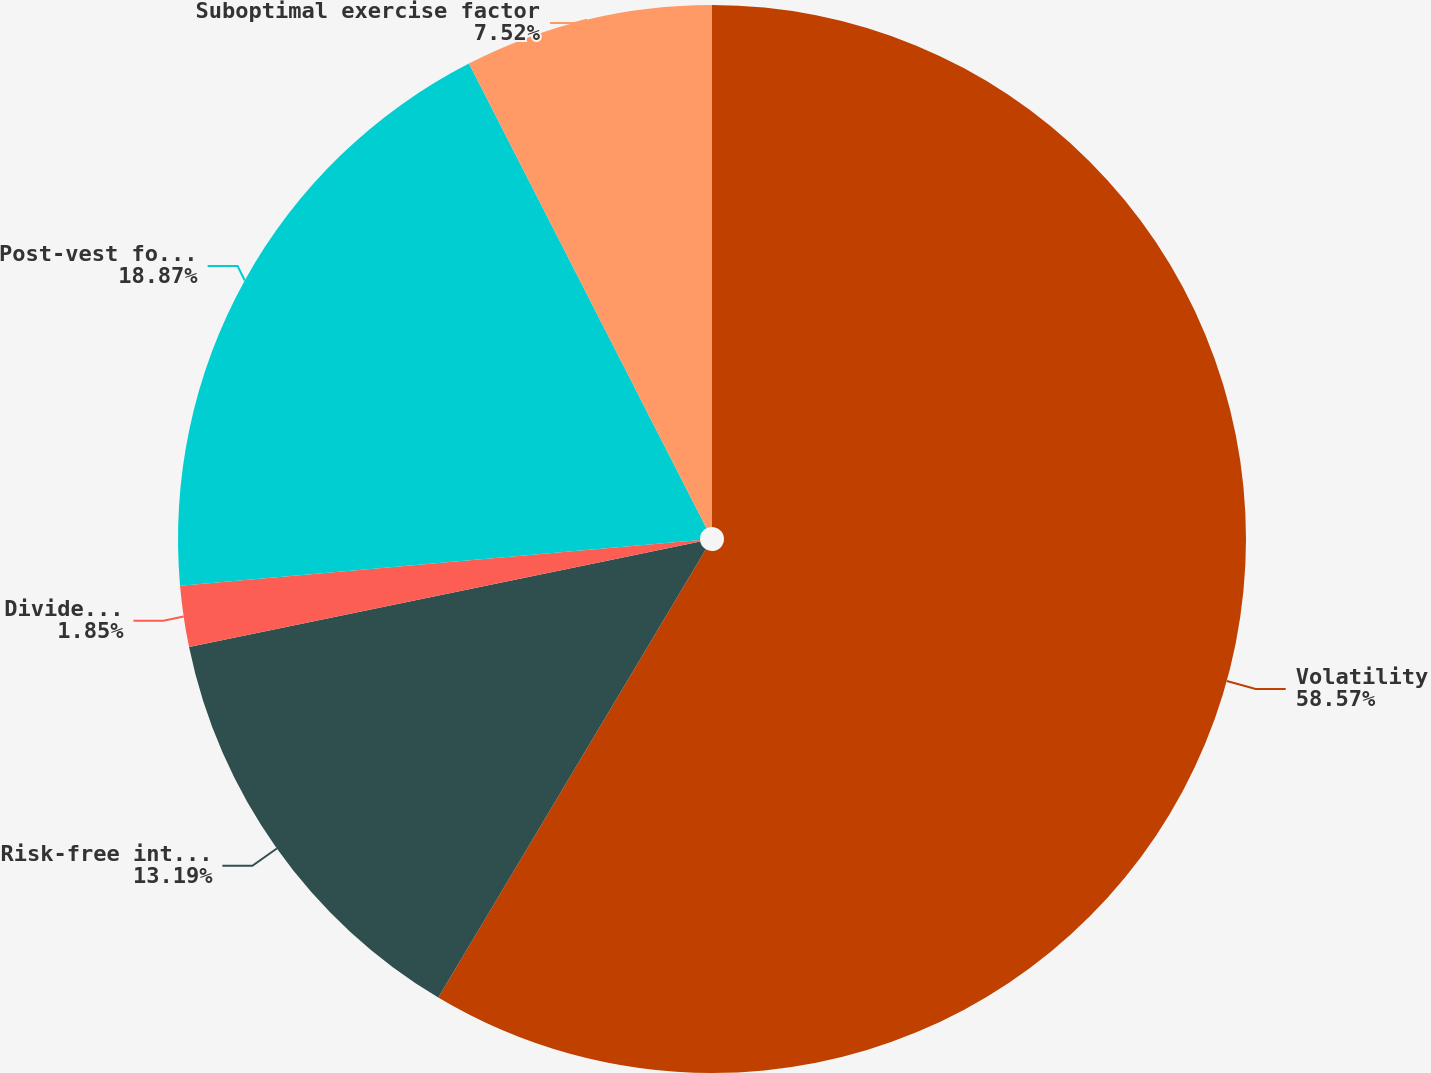Convert chart. <chart><loc_0><loc_0><loc_500><loc_500><pie_chart><fcel>Volatility<fcel>Risk-free interest rate<fcel>Dividend yield<fcel>Post-vest forfeiture rate<fcel>Suboptimal exercise factor<nl><fcel>58.56%<fcel>13.19%<fcel>1.85%<fcel>18.87%<fcel>7.52%<nl></chart> 